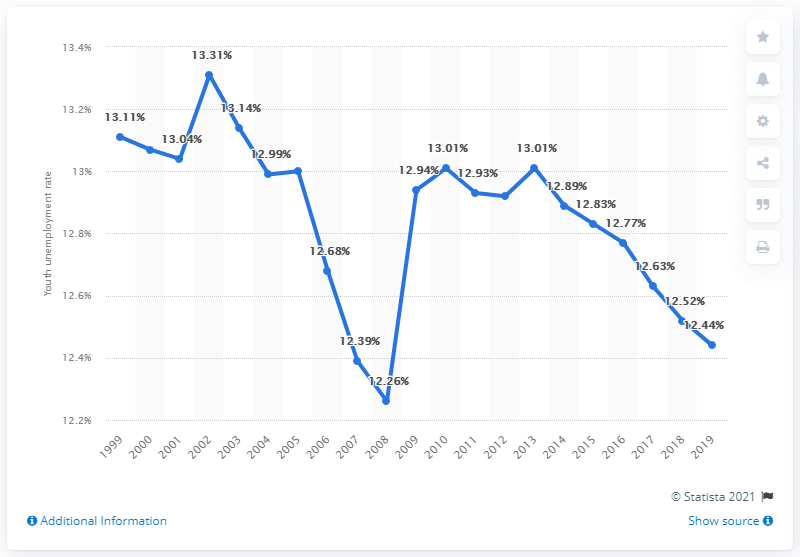What was the youth unemployment rate in the Gambia in 2019?
 12.44 